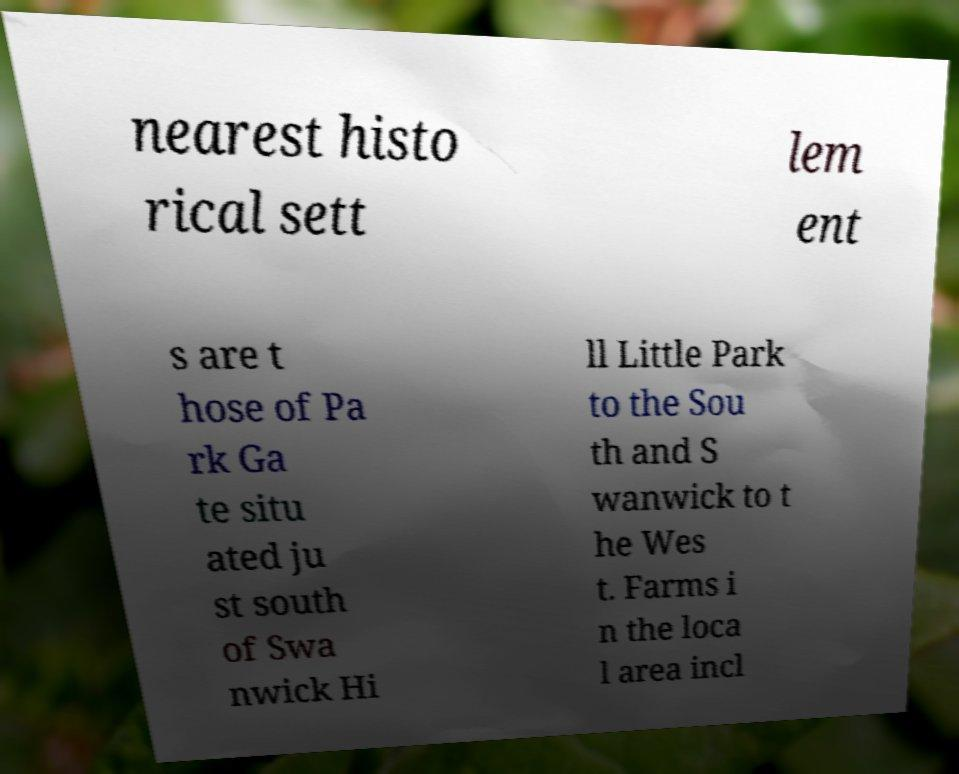Can you accurately transcribe the text from the provided image for me? nearest histo rical sett lem ent s are t hose of Pa rk Ga te situ ated ju st south of Swa nwick Hi ll Little Park to the Sou th and S wanwick to t he Wes t. Farms i n the loca l area incl 